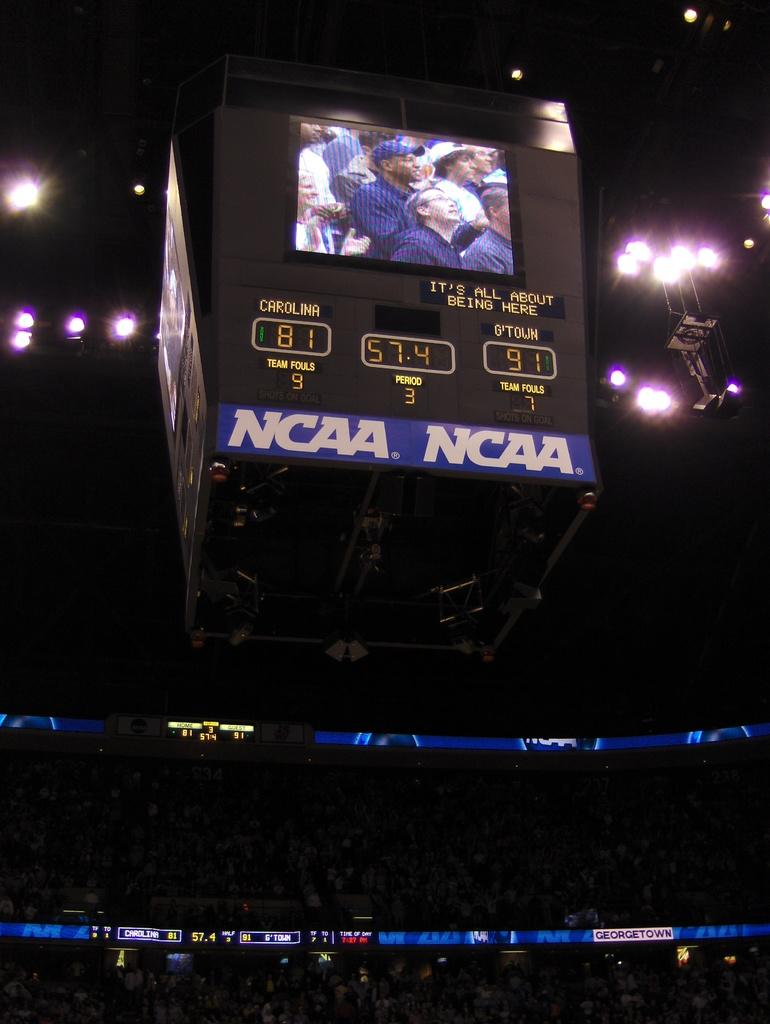<image>
Render a clear and concise summary of the photo. G'town is raking the lead against Carolina in the NCAA championship 